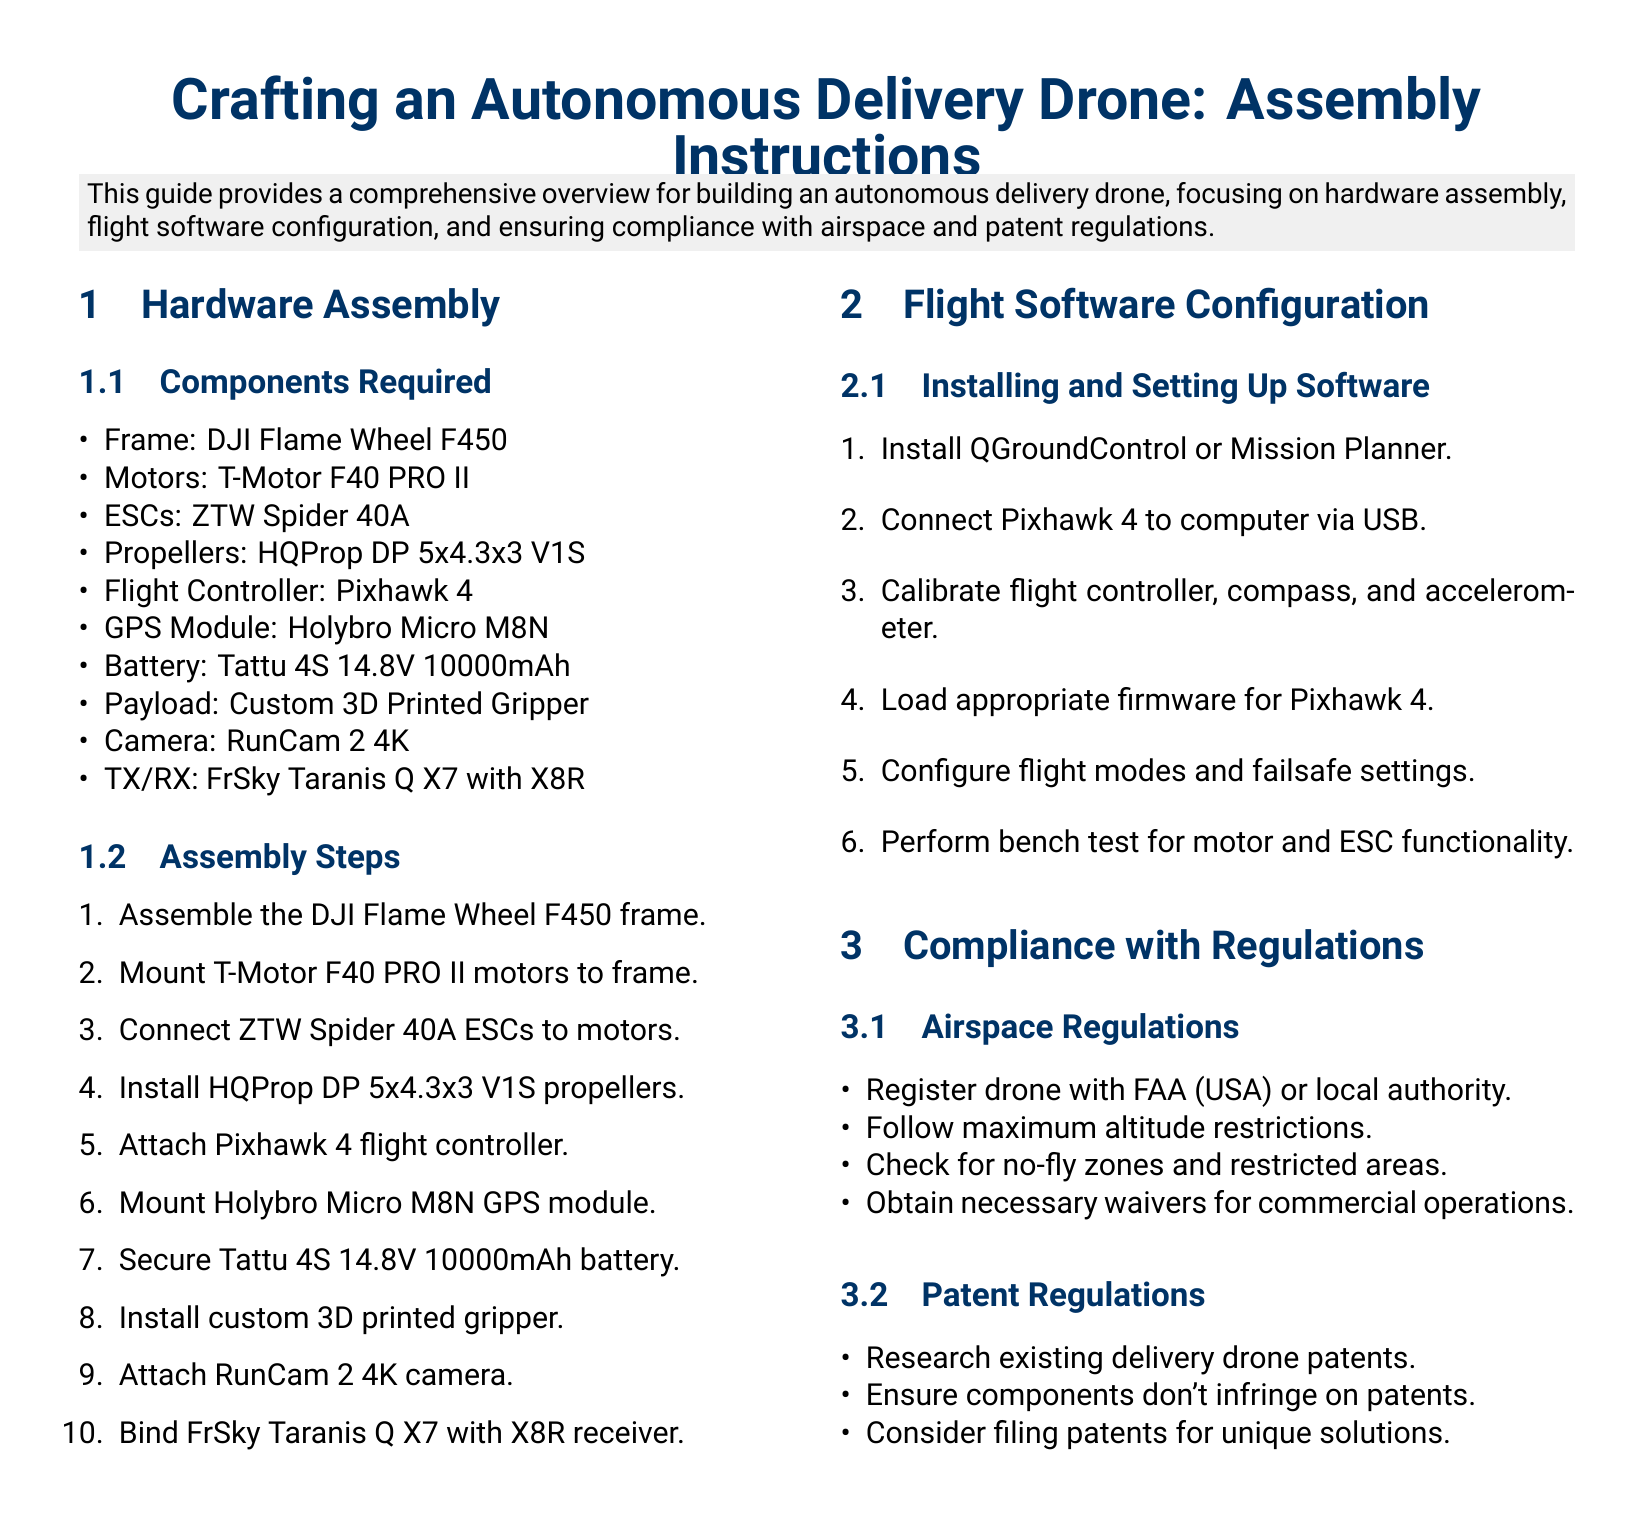What is the frame model used? The frame model used for the drone is specified under the hardware assembly section.
Answer: DJI Flame Wheel F450 How many motors are needed? The section on components required states the number of motors needed for assembly.
Answer: 4 What is the recommended flight software? The flight software section mentions the options for installation and setup for the flight controller.
Answer: QGroundControl or Mission Planner Which battery model is suggested? The components required subsection lists the battery model necessary for the drone assembly.
Answer: Tattu 4S 14.8V 10000mAh What is the first step in assembling the drone? The assembly steps outline a sequence to follow; the first step is listed there.
Answer: Assemble the DJI Flame Wheel F450 frame What component is used for GPS? The components required section highlights the specific GPS module essential for the drone.
Answer: Holybro Micro M8N What is needed to comply with airspace regulations? The compliance section lists specific requirements under airspace regulations, answering this query.
Answer: Register drone with FAA (USA) or local authority How many calibration steps are outlined for the flight controller? The flight software configuration section describes the calibration steps in its list.
Answer: 3 What should be checked for before flying? The airspace regulations section includes safety measures that need to be checked before operation.
Answer: No-fly zones and restricted areas 